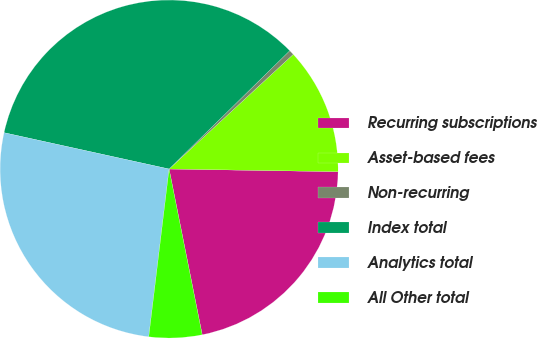<chart> <loc_0><loc_0><loc_500><loc_500><pie_chart><fcel>Recurring subscriptions<fcel>Asset-based fees<fcel>Non-recurring<fcel>Index total<fcel>Analytics total<fcel>All Other total<nl><fcel>21.61%<fcel>12.12%<fcel>0.48%<fcel>34.21%<fcel>26.53%<fcel>5.06%<nl></chart> 